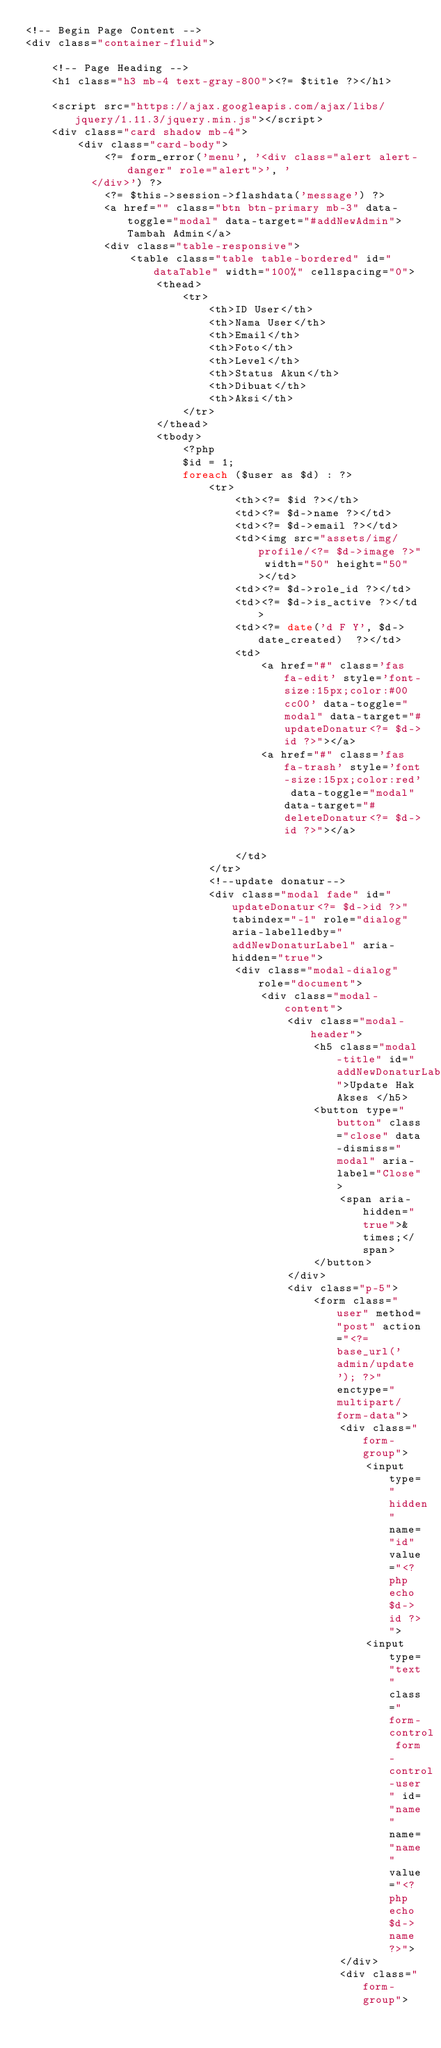<code> <loc_0><loc_0><loc_500><loc_500><_PHP_><!-- Begin Page Content -->
<div class="container-fluid">

    <!-- Page Heading -->
    <h1 class="h3 mb-4 text-gray-800"><?= $title ?></h1>

    <script src="https://ajax.googleapis.com/ajax/libs/jquery/1.11.3/jquery.min.js"></script>
    <div class="card shadow mb-4">
        <div class="card-body">
            <?= form_error('menu', '<div class="alert alert-danger" role="alert">', '
          </div>') ?>
            <?= $this->session->flashdata('message') ?>
            <a href="" class="btn btn-primary mb-3" data-toggle="modal" data-target="#addNewAdmin">Tambah Admin</a>
            <div class="table-responsive">
                <table class="table table-bordered" id="dataTable" width="100%" cellspacing="0">
                    <thead>
                        <tr>
                            <th>ID User</th>
                            <th>Nama User</th>
                            <th>Email</th>
                            <th>Foto</th>
                            <th>Level</th>
                            <th>Status Akun</th>
                            <th>Dibuat</th>
                            <th>Aksi</th>
                        </tr>
                    </thead>
                    <tbody>
                        <?php
                        $id = 1;
                        foreach ($user as $d) : ?>
                            <tr>
                                <th><?= $id ?></th>
                                <td><?= $d->name ?></td>
                                <td><?= $d->email ?></td>
                                <td><img src="assets/img/profile/<?= $d->image ?>" width="50" height="50"></td>
                                <td><?= $d->role_id ?></td>
                                <td><?= $d->is_active ?></td>
                                <td><?= date('d F Y', $d->date_created)  ?></td>
                                <td>
                                    <a href="#" class='fas fa-edit' style='font-size:15px;color:#00cc00' data-toggle="modal" data-target="#updateDonatur<?= $d->id ?>"></a>
                                    <a href="#" class='fas fa-trash' style='font-size:15px;color:red' data-toggle="modal" data-target="#deleteDonatur<?= $d->id ?>"></a>

                                </td>
                            </tr>
                            <!--update donatur-->
                            <div class="modal fade" id="updateDonatur<?= $d->id ?>" tabindex="-1" role="dialog" aria-labelledby="addNewDonaturLabel" aria-hidden="true">
                                <div class="modal-dialog" role="document">
                                    <div class="modal-content">
                                        <div class="modal-header">
                                            <h5 class="modal-title" id="addNewDonaturLabel">Update Hak Akses </h5>
                                            <button type="button" class="close" data-dismiss="modal" aria-label="Close">
                                                <span aria-hidden="true">&times;</span>
                                            </button>
                                        </div>
                                        <div class="p-5">
                                            <form class="user" method="post" action="<?= base_url('admin/update'); ?>" enctype="multipart/form-data">
                                                <div class="form-group">
                                                    <input type="hidden" name="id" value="<?php echo $d->id ?>">
                                                    <input type="text" class="form-control form-control-user" id="name" name="name" value="<?php echo $d->name ?>">
                                                </div>
                                                <div class="form-group"></code> 